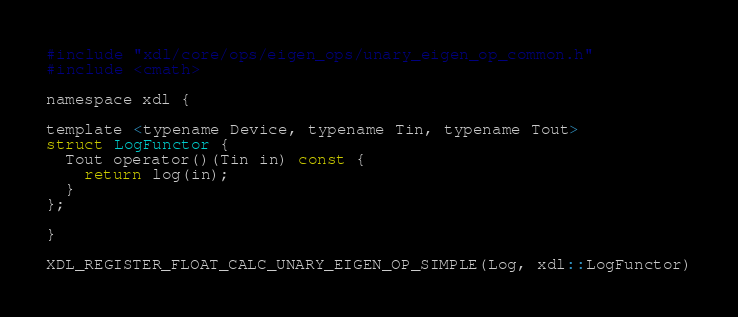<code> <loc_0><loc_0><loc_500><loc_500><_Cuda_>#include "xdl/core/ops/eigen_ops/unary_eigen_op_common.h"
#include <cmath>

namespace xdl {

template <typename Device, typename Tin, typename Tout>
struct LogFunctor {
  Tout operator()(Tin in) const {
    return log(in);
  }
};

}

XDL_REGISTER_FLOAT_CALC_UNARY_EIGEN_OP_SIMPLE(Log, xdl::LogFunctor)
</code> 